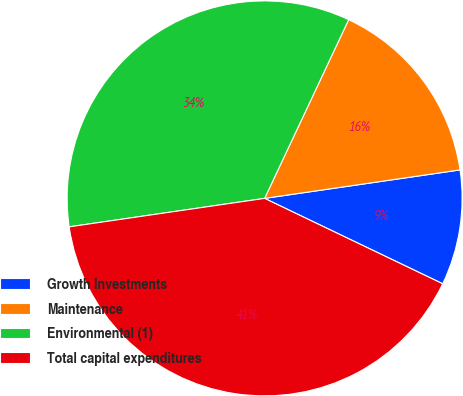Convert chart. <chart><loc_0><loc_0><loc_500><loc_500><pie_chart><fcel>Growth Investments<fcel>Maintenance<fcel>Environmental (1)<fcel>Total capital expenditures<nl><fcel>9.42%<fcel>15.7%<fcel>34.3%<fcel>40.58%<nl></chart> 